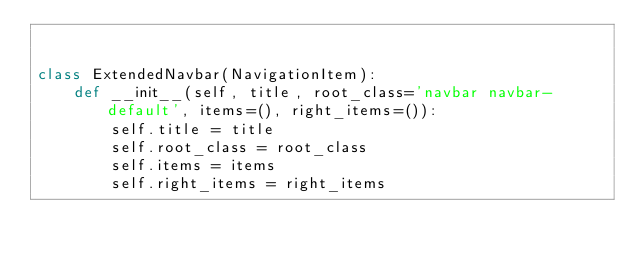Convert code to text. <code><loc_0><loc_0><loc_500><loc_500><_Python_>

class ExtendedNavbar(NavigationItem):
    def __init__(self, title, root_class='navbar navbar-default', items=(), right_items=()):
        self.title = title
        self.root_class = root_class
        self.items = items
        self.right_items = right_items
</code> 